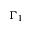<formula> <loc_0><loc_0><loc_500><loc_500>\Gamma _ { 1 }</formula> 